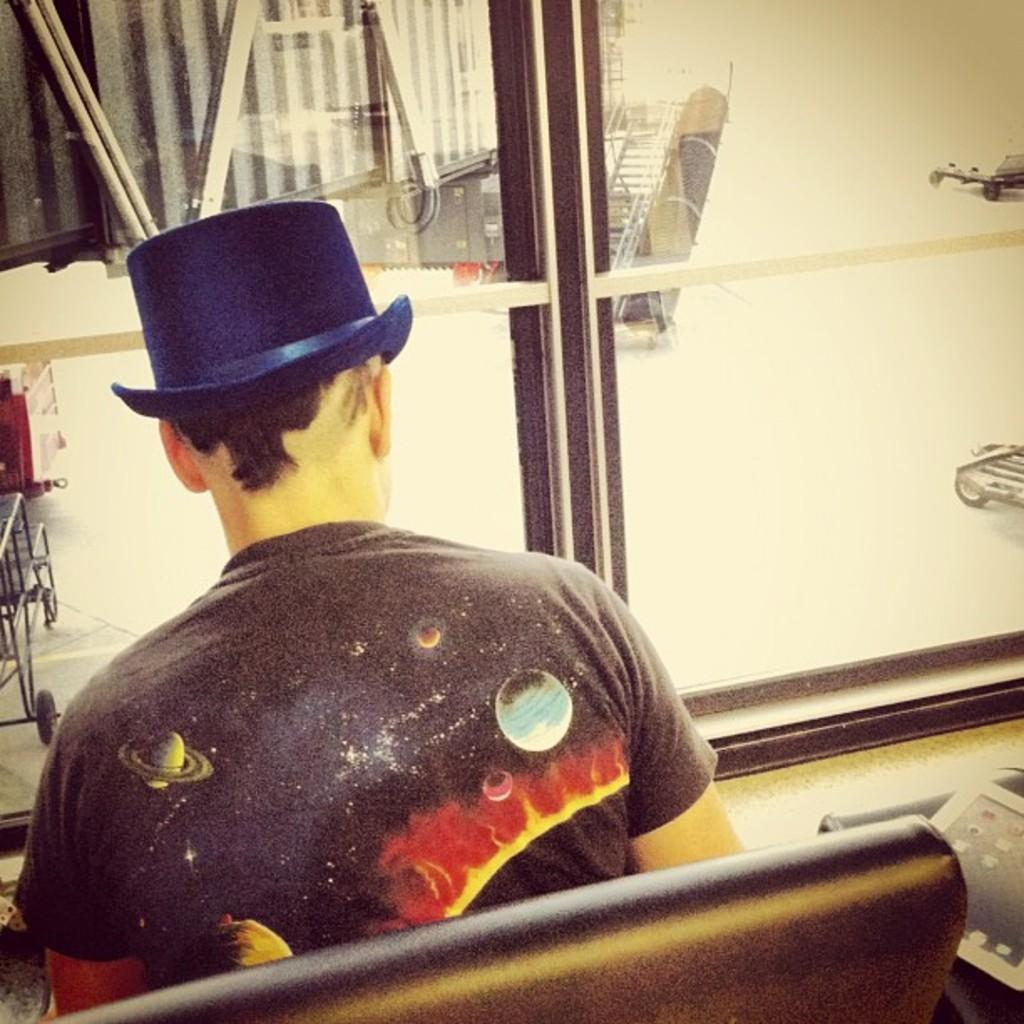Who is in the image? There is a man in the image. What is the man wearing on his head? The man is wearing a cap. What is the man doing in the image? The man is sitting on a chair. What color can be seen in the image? There is tan visible in the image. What else can be seen in the image besides the man? There are objects present in the image. What type of pet is the man holding in the image? There is no pet present in the image; the man is sitting on a chair and wearing a cap. 